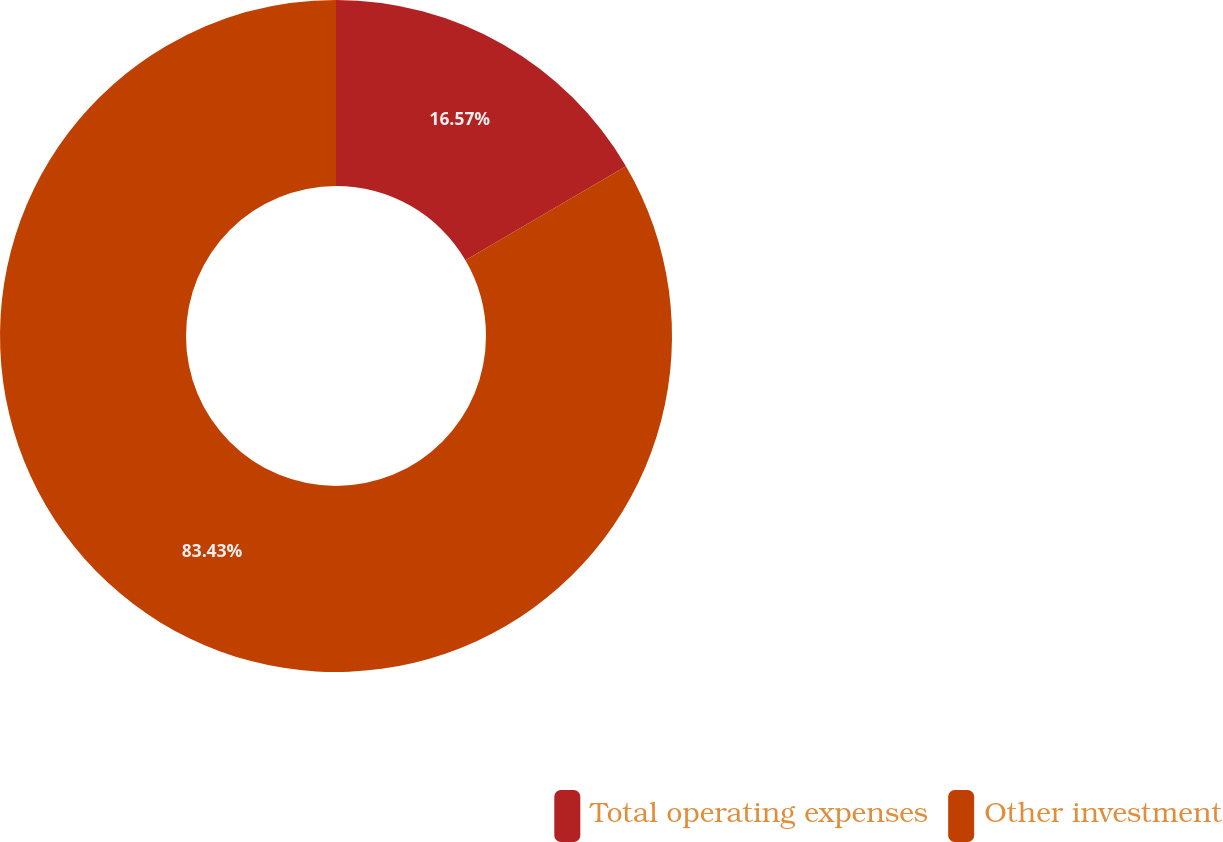<chart> <loc_0><loc_0><loc_500><loc_500><pie_chart><fcel>Total operating expenses<fcel>Other investment<nl><fcel>16.57%<fcel>83.43%<nl></chart> 